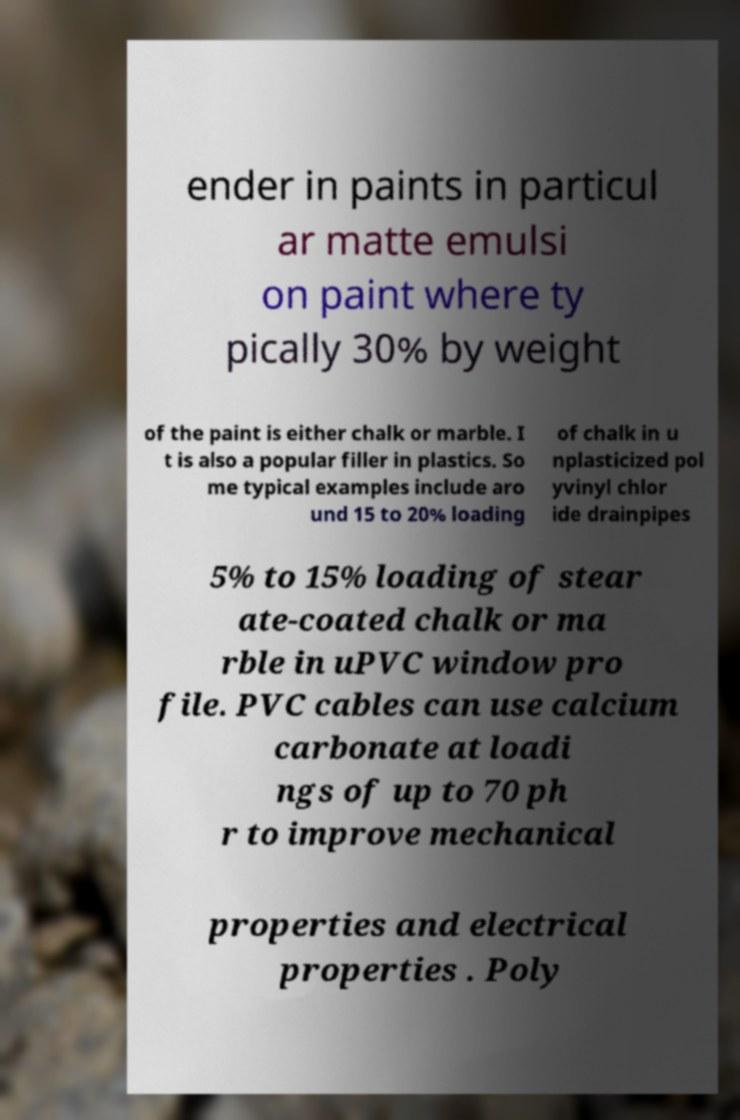Can you accurately transcribe the text from the provided image for me? ender in paints in particul ar matte emulsi on paint where ty pically 30% by weight of the paint is either chalk or marble. I t is also a popular filler in plastics. So me typical examples include aro und 15 to 20% loading of chalk in u nplasticized pol yvinyl chlor ide drainpipes 5% to 15% loading of stear ate-coated chalk or ma rble in uPVC window pro file. PVC cables can use calcium carbonate at loadi ngs of up to 70 ph r to improve mechanical properties and electrical properties . Poly 